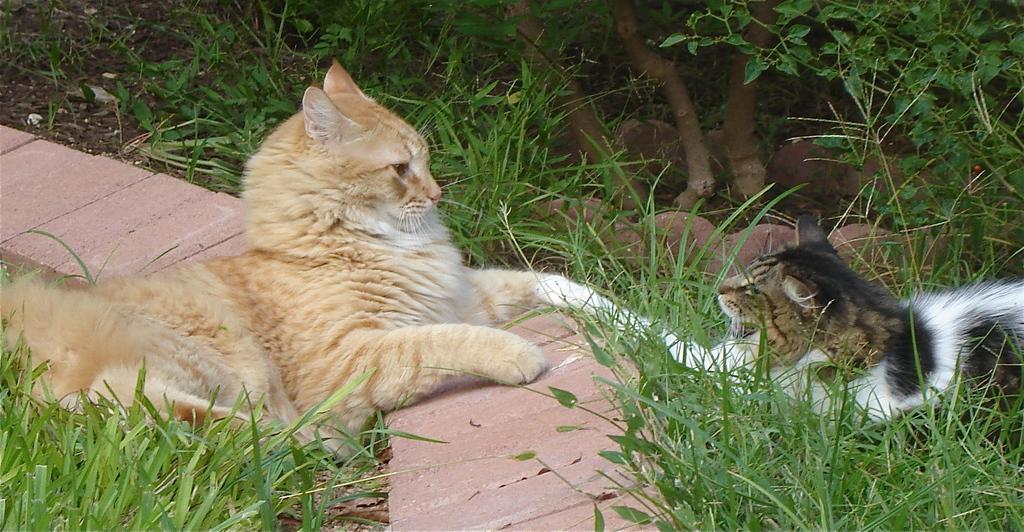Can you describe this image briefly? In this image I can see two cats on grass, fence and plants. This image is taken may be in a park during a day. 